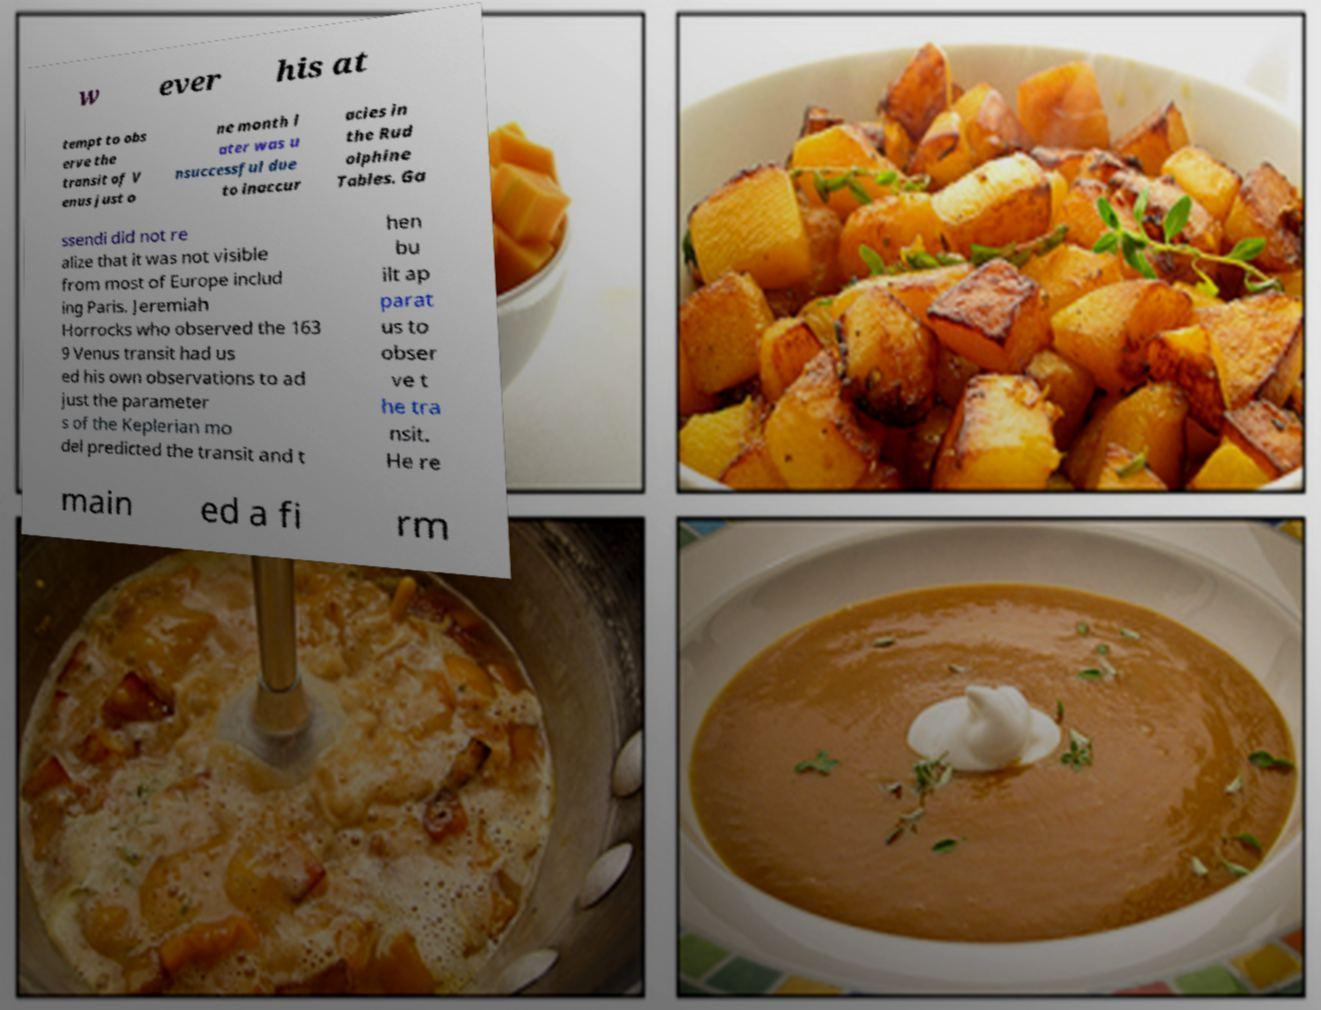There's text embedded in this image that I need extracted. Can you transcribe it verbatim? w ever his at tempt to obs erve the transit of V enus just o ne month l ater was u nsuccessful due to inaccur acies in the Rud olphine Tables. Ga ssendi did not re alize that it was not visible from most of Europe includ ing Paris. Jeremiah Horrocks who observed the 163 9 Venus transit had us ed his own observations to ad just the parameter s of the Keplerian mo del predicted the transit and t hen bu ilt ap parat us to obser ve t he tra nsit. He re main ed a fi rm 